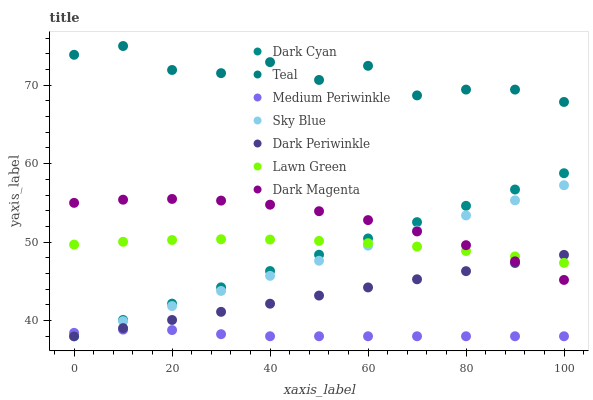Does Medium Periwinkle have the minimum area under the curve?
Answer yes or no. Yes. Does Teal have the maximum area under the curve?
Answer yes or no. Yes. Does Dark Magenta have the minimum area under the curve?
Answer yes or no. No. Does Dark Magenta have the maximum area under the curve?
Answer yes or no. No. Is Dark Periwinkle the smoothest?
Answer yes or no. Yes. Is Teal the roughest?
Answer yes or no. Yes. Is Dark Magenta the smoothest?
Answer yes or no. No. Is Dark Magenta the roughest?
Answer yes or no. No. Does Medium Periwinkle have the lowest value?
Answer yes or no. Yes. Does Dark Magenta have the lowest value?
Answer yes or no. No. Does Teal have the highest value?
Answer yes or no. Yes. Does Dark Magenta have the highest value?
Answer yes or no. No. Is Dark Magenta less than Teal?
Answer yes or no. Yes. Is Dark Magenta greater than Medium Periwinkle?
Answer yes or no. Yes. Does Lawn Green intersect Dark Periwinkle?
Answer yes or no. Yes. Is Lawn Green less than Dark Periwinkle?
Answer yes or no. No. Is Lawn Green greater than Dark Periwinkle?
Answer yes or no. No. Does Dark Magenta intersect Teal?
Answer yes or no. No. 